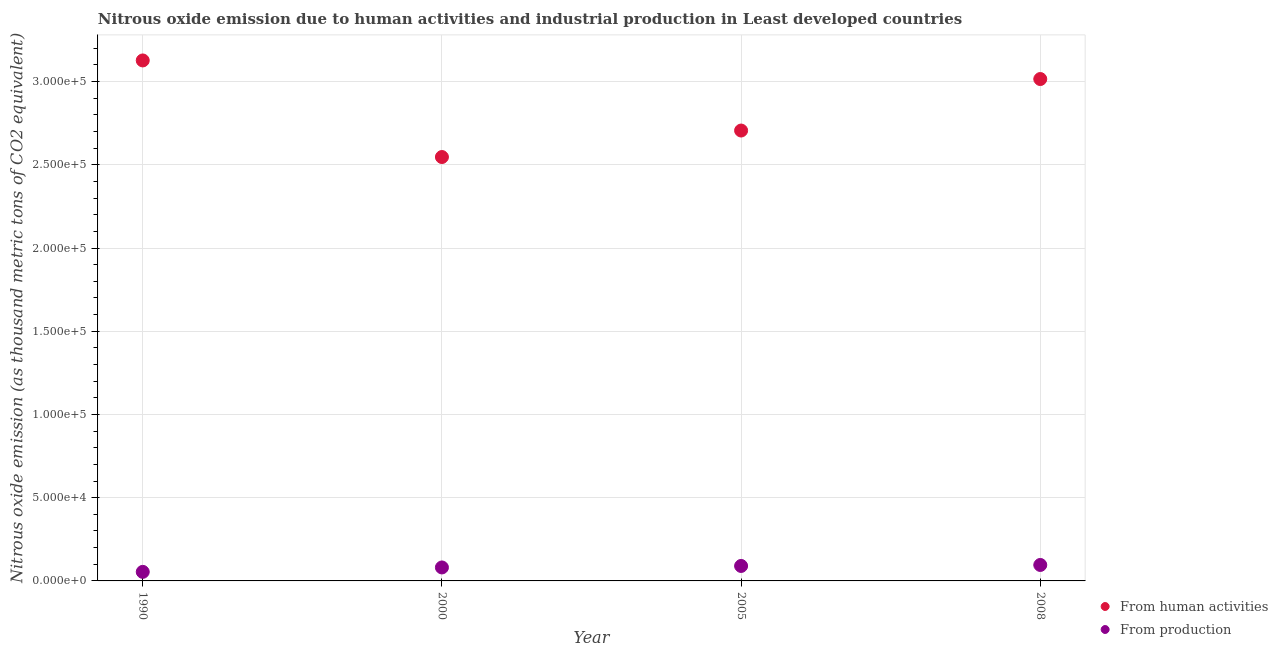Is the number of dotlines equal to the number of legend labels?
Provide a short and direct response. Yes. What is the amount of emissions generated from industries in 2008?
Make the answer very short. 9587.5. Across all years, what is the maximum amount of emissions from human activities?
Offer a terse response. 3.13e+05. Across all years, what is the minimum amount of emissions generated from industries?
Make the answer very short. 5438.5. In which year was the amount of emissions generated from industries minimum?
Offer a very short reply. 1990. What is the total amount of emissions from human activities in the graph?
Keep it short and to the point. 1.14e+06. What is the difference between the amount of emissions from human activities in 1990 and that in 2008?
Keep it short and to the point. 1.12e+04. What is the difference between the amount of emissions generated from industries in 2008 and the amount of emissions from human activities in 2005?
Your answer should be very brief. -2.61e+05. What is the average amount of emissions from human activities per year?
Your answer should be compact. 2.85e+05. In the year 1990, what is the difference between the amount of emissions generated from industries and amount of emissions from human activities?
Make the answer very short. -3.07e+05. In how many years, is the amount of emissions from human activities greater than 160000 thousand metric tons?
Keep it short and to the point. 4. What is the ratio of the amount of emissions generated from industries in 2000 to that in 2005?
Give a very brief answer. 0.9. What is the difference between the highest and the second highest amount of emissions from human activities?
Your response must be concise. 1.12e+04. What is the difference between the highest and the lowest amount of emissions generated from industries?
Your answer should be very brief. 4149. In how many years, is the amount of emissions from human activities greater than the average amount of emissions from human activities taken over all years?
Provide a short and direct response. 2. Is the sum of the amount of emissions from human activities in 2000 and 2008 greater than the maximum amount of emissions generated from industries across all years?
Offer a very short reply. Yes. Does the amount of emissions generated from industries monotonically increase over the years?
Keep it short and to the point. Yes. Is the amount of emissions from human activities strictly greater than the amount of emissions generated from industries over the years?
Provide a short and direct response. Yes. Is the amount of emissions from human activities strictly less than the amount of emissions generated from industries over the years?
Your answer should be very brief. No. How many dotlines are there?
Offer a very short reply. 2. How many years are there in the graph?
Your answer should be compact. 4. What is the difference between two consecutive major ticks on the Y-axis?
Ensure brevity in your answer.  5.00e+04. Does the graph contain grids?
Your answer should be compact. Yes. How many legend labels are there?
Offer a very short reply. 2. How are the legend labels stacked?
Provide a short and direct response. Vertical. What is the title of the graph?
Give a very brief answer. Nitrous oxide emission due to human activities and industrial production in Least developed countries. What is the label or title of the X-axis?
Provide a short and direct response. Year. What is the label or title of the Y-axis?
Offer a very short reply. Nitrous oxide emission (as thousand metric tons of CO2 equivalent). What is the Nitrous oxide emission (as thousand metric tons of CO2 equivalent) in From human activities in 1990?
Provide a succinct answer. 3.13e+05. What is the Nitrous oxide emission (as thousand metric tons of CO2 equivalent) in From production in 1990?
Provide a short and direct response. 5438.5. What is the Nitrous oxide emission (as thousand metric tons of CO2 equivalent) in From human activities in 2000?
Provide a short and direct response. 2.55e+05. What is the Nitrous oxide emission (as thousand metric tons of CO2 equivalent) of From production in 2000?
Provide a succinct answer. 8093.3. What is the Nitrous oxide emission (as thousand metric tons of CO2 equivalent) of From human activities in 2005?
Keep it short and to the point. 2.71e+05. What is the Nitrous oxide emission (as thousand metric tons of CO2 equivalent) of From production in 2005?
Offer a terse response. 8989.7. What is the Nitrous oxide emission (as thousand metric tons of CO2 equivalent) of From human activities in 2008?
Your answer should be compact. 3.02e+05. What is the Nitrous oxide emission (as thousand metric tons of CO2 equivalent) in From production in 2008?
Keep it short and to the point. 9587.5. Across all years, what is the maximum Nitrous oxide emission (as thousand metric tons of CO2 equivalent) in From human activities?
Keep it short and to the point. 3.13e+05. Across all years, what is the maximum Nitrous oxide emission (as thousand metric tons of CO2 equivalent) of From production?
Your answer should be very brief. 9587.5. Across all years, what is the minimum Nitrous oxide emission (as thousand metric tons of CO2 equivalent) in From human activities?
Offer a very short reply. 2.55e+05. Across all years, what is the minimum Nitrous oxide emission (as thousand metric tons of CO2 equivalent) in From production?
Ensure brevity in your answer.  5438.5. What is the total Nitrous oxide emission (as thousand metric tons of CO2 equivalent) in From human activities in the graph?
Provide a succinct answer. 1.14e+06. What is the total Nitrous oxide emission (as thousand metric tons of CO2 equivalent) in From production in the graph?
Offer a terse response. 3.21e+04. What is the difference between the Nitrous oxide emission (as thousand metric tons of CO2 equivalent) of From human activities in 1990 and that in 2000?
Give a very brief answer. 5.80e+04. What is the difference between the Nitrous oxide emission (as thousand metric tons of CO2 equivalent) of From production in 1990 and that in 2000?
Your response must be concise. -2654.8. What is the difference between the Nitrous oxide emission (as thousand metric tons of CO2 equivalent) in From human activities in 1990 and that in 2005?
Your answer should be compact. 4.21e+04. What is the difference between the Nitrous oxide emission (as thousand metric tons of CO2 equivalent) of From production in 1990 and that in 2005?
Ensure brevity in your answer.  -3551.2. What is the difference between the Nitrous oxide emission (as thousand metric tons of CO2 equivalent) of From human activities in 1990 and that in 2008?
Make the answer very short. 1.12e+04. What is the difference between the Nitrous oxide emission (as thousand metric tons of CO2 equivalent) of From production in 1990 and that in 2008?
Keep it short and to the point. -4149. What is the difference between the Nitrous oxide emission (as thousand metric tons of CO2 equivalent) of From human activities in 2000 and that in 2005?
Ensure brevity in your answer.  -1.59e+04. What is the difference between the Nitrous oxide emission (as thousand metric tons of CO2 equivalent) of From production in 2000 and that in 2005?
Offer a very short reply. -896.4. What is the difference between the Nitrous oxide emission (as thousand metric tons of CO2 equivalent) of From human activities in 2000 and that in 2008?
Keep it short and to the point. -4.69e+04. What is the difference between the Nitrous oxide emission (as thousand metric tons of CO2 equivalent) in From production in 2000 and that in 2008?
Make the answer very short. -1494.2. What is the difference between the Nitrous oxide emission (as thousand metric tons of CO2 equivalent) in From human activities in 2005 and that in 2008?
Offer a very short reply. -3.09e+04. What is the difference between the Nitrous oxide emission (as thousand metric tons of CO2 equivalent) of From production in 2005 and that in 2008?
Offer a very short reply. -597.8. What is the difference between the Nitrous oxide emission (as thousand metric tons of CO2 equivalent) of From human activities in 1990 and the Nitrous oxide emission (as thousand metric tons of CO2 equivalent) of From production in 2000?
Ensure brevity in your answer.  3.05e+05. What is the difference between the Nitrous oxide emission (as thousand metric tons of CO2 equivalent) in From human activities in 1990 and the Nitrous oxide emission (as thousand metric tons of CO2 equivalent) in From production in 2005?
Your response must be concise. 3.04e+05. What is the difference between the Nitrous oxide emission (as thousand metric tons of CO2 equivalent) of From human activities in 1990 and the Nitrous oxide emission (as thousand metric tons of CO2 equivalent) of From production in 2008?
Your response must be concise. 3.03e+05. What is the difference between the Nitrous oxide emission (as thousand metric tons of CO2 equivalent) in From human activities in 2000 and the Nitrous oxide emission (as thousand metric tons of CO2 equivalent) in From production in 2005?
Your response must be concise. 2.46e+05. What is the difference between the Nitrous oxide emission (as thousand metric tons of CO2 equivalent) in From human activities in 2000 and the Nitrous oxide emission (as thousand metric tons of CO2 equivalent) in From production in 2008?
Your answer should be compact. 2.45e+05. What is the difference between the Nitrous oxide emission (as thousand metric tons of CO2 equivalent) of From human activities in 2005 and the Nitrous oxide emission (as thousand metric tons of CO2 equivalent) of From production in 2008?
Your answer should be compact. 2.61e+05. What is the average Nitrous oxide emission (as thousand metric tons of CO2 equivalent) of From human activities per year?
Give a very brief answer. 2.85e+05. What is the average Nitrous oxide emission (as thousand metric tons of CO2 equivalent) in From production per year?
Offer a terse response. 8027.25. In the year 1990, what is the difference between the Nitrous oxide emission (as thousand metric tons of CO2 equivalent) in From human activities and Nitrous oxide emission (as thousand metric tons of CO2 equivalent) in From production?
Your answer should be compact. 3.07e+05. In the year 2000, what is the difference between the Nitrous oxide emission (as thousand metric tons of CO2 equivalent) of From human activities and Nitrous oxide emission (as thousand metric tons of CO2 equivalent) of From production?
Ensure brevity in your answer.  2.47e+05. In the year 2005, what is the difference between the Nitrous oxide emission (as thousand metric tons of CO2 equivalent) in From human activities and Nitrous oxide emission (as thousand metric tons of CO2 equivalent) in From production?
Ensure brevity in your answer.  2.62e+05. In the year 2008, what is the difference between the Nitrous oxide emission (as thousand metric tons of CO2 equivalent) of From human activities and Nitrous oxide emission (as thousand metric tons of CO2 equivalent) of From production?
Your answer should be compact. 2.92e+05. What is the ratio of the Nitrous oxide emission (as thousand metric tons of CO2 equivalent) of From human activities in 1990 to that in 2000?
Provide a succinct answer. 1.23. What is the ratio of the Nitrous oxide emission (as thousand metric tons of CO2 equivalent) of From production in 1990 to that in 2000?
Give a very brief answer. 0.67. What is the ratio of the Nitrous oxide emission (as thousand metric tons of CO2 equivalent) of From human activities in 1990 to that in 2005?
Provide a succinct answer. 1.16. What is the ratio of the Nitrous oxide emission (as thousand metric tons of CO2 equivalent) of From production in 1990 to that in 2005?
Give a very brief answer. 0.6. What is the ratio of the Nitrous oxide emission (as thousand metric tons of CO2 equivalent) of From production in 1990 to that in 2008?
Ensure brevity in your answer.  0.57. What is the ratio of the Nitrous oxide emission (as thousand metric tons of CO2 equivalent) in From production in 2000 to that in 2005?
Make the answer very short. 0.9. What is the ratio of the Nitrous oxide emission (as thousand metric tons of CO2 equivalent) of From human activities in 2000 to that in 2008?
Your response must be concise. 0.84. What is the ratio of the Nitrous oxide emission (as thousand metric tons of CO2 equivalent) in From production in 2000 to that in 2008?
Offer a very short reply. 0.84. What is the ratio of the Nitrous oxide emission (as thousand metric tons of CO2 equivalent) of From human activities in 2005 to that in 2008?
Provide a succinct answer. 0.9. What is the ratio of the Nitrous oxide emission (as thousand metric tons of CO2 equivalent) of From production in 2005 to that in 2008?
Your response must be concise. 0.94. What is the difference between the highest and the second highest Nitrous oxide emission (as thousand metric tons of CO2 equivalent) of From human activities?
Your answer should be compact. 1.12e+04. What is the difference between the highest and the second highest Nitrous oxide emission (as thousand metric tons of CO2 equivalent) in From production?
Give a very brief answer. 597.8. What is the difference between the highest and the lowest Nitrous oxide emission (as thousand metric tons of CO2 equivalent) of From human activities?
Offer a terse response. 5.80e+04. What is the difference between the highest and the lowest Nitrous oxide emission (as thousand metric tons of CO2 equivalent) in From production?
Provide a succinct answer. 4149. 